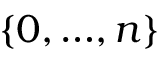Convert formula to latex. <formula><loc_0><loc_0><loc_500><loc_500>\left \{ 0 , { \dots } , n \right \}</formula> 